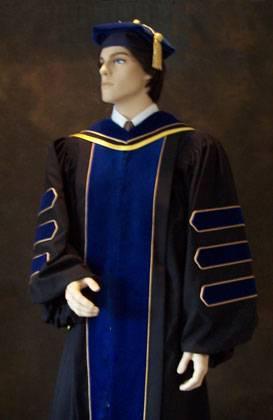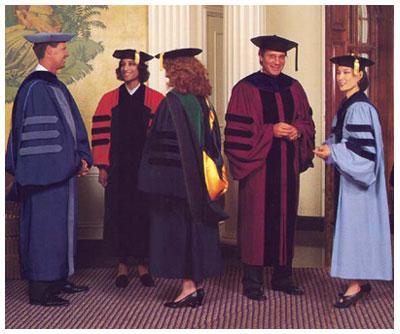The first image is the image on the left, the second image is the image on the right. For the images displayed, is the sentence "There are two people in every image wearing graduation caps." factually correct? Answer yes or no. No. The first image is the image on the left, the second image is the image on the right. For the images displayed, is the sentence "An image of a group of graduates includes a female with red hair and back turned to the camera." factually correct? Answer yes or no. Yes. 